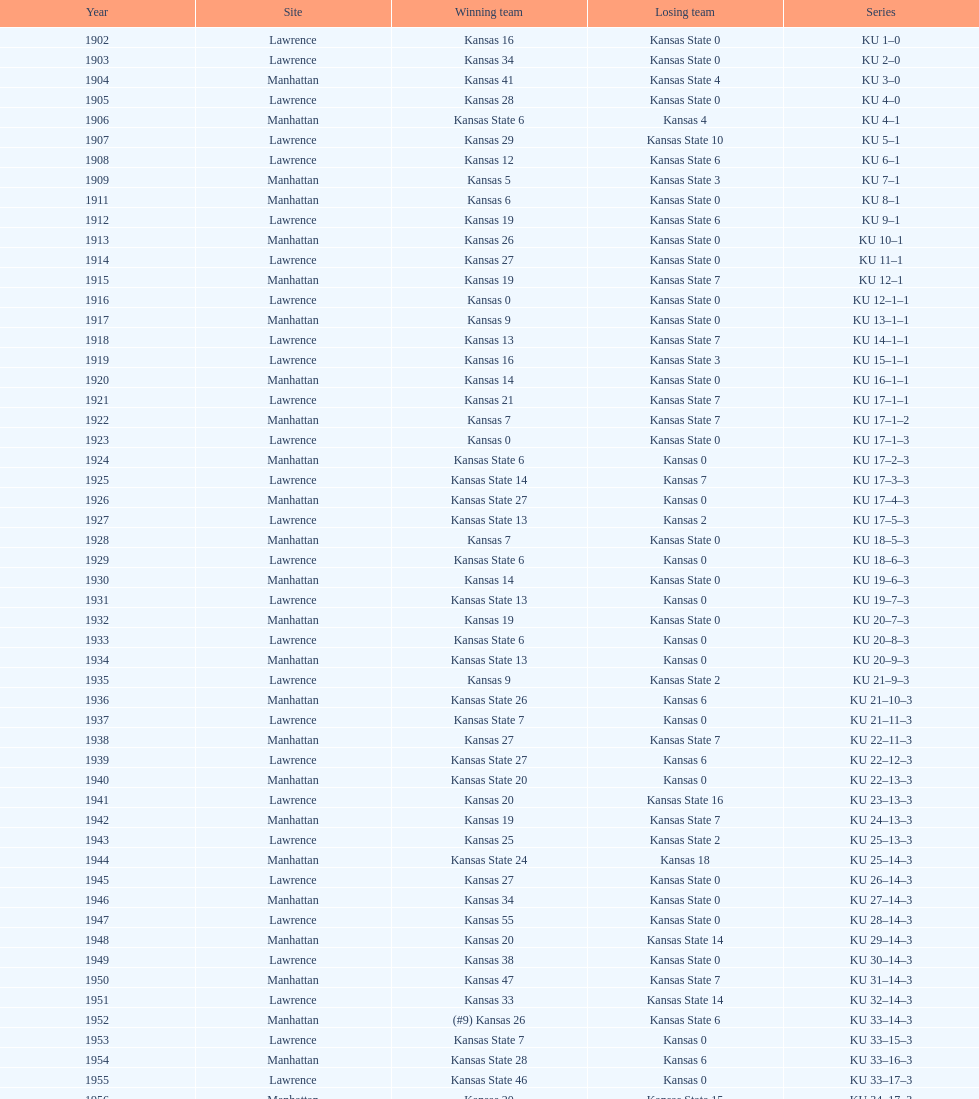Could you parse the entire table? {'header': ['Year', 'Site', 'Winning team', 'Losing team', 'Series'], 'rows': [['1902', 'Lawrence', 'Kansas 16', 'Kansas State 0', 'KU 1–0'], ['1903', 'Lawrence', 'Kansas 34', 'Kansas State 0', 'KU 2–0'], ['1904', 'Manhattan', 'Kansas 41', 'Kansas State 4', 'KU 3–0'], ['1905', 'Lawrence', 'Kansas 28', 'Kansas State 0', 'KU 4–0'], ['1906', 'Manhattan', 'Kansas State 6', 'Kansas 4', 'KU 4–1'], ['1907', 'Lawrence', 'Kansas 29', 'Kansas State 10', 'KU 5–1'], ['1908', 'Lawrence', 'Kansas 12', 'Kansas State 6', 'KU 6–1'], ['1909', 'Manhattan', 'Kansas 5', 'Kansas State 3', 'KU 7–1'], ['1911', 'Manhattan', 'Kansas 6', 'Kansas State 0', 'KU 8–1'], ['1912', 'Lawrence', 'Kansas 19', 'Kansas State 6', 'KU 9–1'], ['1913', 'Manhattan', 'Kansas 26', 'Kansas State 0', 'KU 10–1'], ['1914', 'Lawrence', 'Kansas 27', 'Kansas State 0', 'KU 11–1'], ['1915', 'Manhattan', 'Kansas 19', 'Kansas State 7', 'KU 12–1'], ['1916', 'Lawrence', 'Kansas 0', 'Kansas State 0', 'KU 12–1–1'], ['1917', 'Manhattan', 'Kansas 9', 'Kansas State 0', 'KU 13–1–1'], ['1918', 'Lawrence', 'Kansas 13', 'Kansas State 7', 'KU 14–1–1'], ['1919', 'Lawrence', 'Kansas 16', 'Kansas State 3', 'KU 15–1–1'], ['1920', 'Manhattan', 'Kansas 14', 'Kansas State 0', 'KU 16–1–1'], ['1921', 'Lawrence', 'Kansas 21', 'Kansas State 7', 'KU 17–1–1'], ['1922', 'Manhattan', 'Kansas 7', 'Kansas State 7', 'KU 17–1–2'], ['1923', 'Lawrence', 'Kansas 0', 'Kansas State 0', 'KU 17–1–3'], ['1924', 'Manhattan', 'Kansas State 6', 'Kansas 0', 'KU 17–2–3'], ['1925', 'Lawrence', 'Kansas State 14', 'Kansas 7', 'KU 17–3–3'], ['1926', 'Manhattan', 'Kansas State 27', 'Kansas 0', 'KU 17–4–3'], ['1927', 'Lawrence', 'Kansas State 13', 'Kansas 2', 'KU 17–5–3'], ['1928', 'Manhattan', 'Kansas 7', 'Kansas State 0', 'KU 18–5–3'], ['1929', 'Lawrence', 'Kansas State 6', 'Kansas 0', 'KU 18–6–3'], ['1930', 'Manhattan', 'Kansas 14', 'Kansas State 0', 'KU 19–6–3'], ['1931', 'Lawrence', 'Kansas State 13', 'Kansas 0', 'KU 19–7–3'], ['1932', 'Manhattan', 'Kansas 19', 'Kansas State 0', 'KU 20–7–3'], ['1933', 'Lawrence', 'Kansas State 6', 'Kansas 0', 'KU 20–8–3'], ['1934', 'Manhattan', 'Kansas State 13', 'Kansas 0', 'KU 20–9–3'], ['1935', 'Lawrence', 'Kansas 9', 'Kansas State 2', 'KU 21–9–3'], ['1936', 'Manhattan', 'Kansas State 26', 'Kansas 6', 'KU 21–10–3'], ['1937', 'Lawrence', 'Kansas State 7', 'Kansas 0', 'KU 21–11–3'], ['1938', 'Manhattan', 'Kansas 27', 'Kansas State 7', 'KU 22–11–3'], ['1939', 'Lawrence', 'Kansas State 27', 'Kansas 6', 'KU 22–12–3'], ['1940', 'Manhattan', 'Kansas State 20', 'Kansas 0', 'KU 22–13–3'], ['1941', 'Lawrence', 'Kansas 20', 'Kansas State 16', 'KU 23–13–3'], ['1942', 'Manhattan', 'Kansas 19', 'Kansas State 7', 'KU 24–13–3'], ['1943', 'Lawrence', 'Kansas 25', 'Kansas State 2', 'KU 25–13–3'], ['1944', 'Manhattan', 'Kansas State 24', 'Kansas 18', 'KU 25–14–3'], ['1945', 'Lawrence', 'Kansas 27', 'Kansas State 0', 'KU 26–14–3'], ['1946', 'Manhattan', 'Kansas 34', 'Kansas State 0', 'KU 27–14–3'], ['1947', 'Lawrence', 'Kansas 55', 'Kansas State 0', 'KU 28–14–3'], ['1948', 'Manhattan', 'Kansas 20', 'Kansas State 14', 'KU 29–14–3'], ['1949', 'Lawrence', 'Kansas 38', 'Kansas State 0', 'KU 30–14–3'], ['1950', 'Manhattan', 'Kansas 47', 'Kansas State 7', 'KU 31–14–3'], ['1951', 'Lawrence', 'Kansas 33', 'Kansas State 14', 'KU 32–14–3'], ['1952', 'Manhattan', '(#9) Kansas 26', 'Kansas State 6', 'KU 33–14–3'], ['1953', 'Lawrence', 'Kansas State 7', 'Kansas 0', 'KU 33–15–3'], ['1954', 'Manhattan', 'Kansas State 28', 'Kansas 6', 'KU 33–16–3'], ['1955', 'Lawrence', 'Kansas State 46', 'Kansas 0', 'KU 33–17–3'], ['1956', 'Manhattan', 'Kansas 20', 'Kansas State 15', 'KU 34–17–3'], ['1957', 'Lawrence', 'Kansas 13', 'Kansas State 7', 'KU 35–17–3'], ['1958', 'Manhattan', 'Kansas 21', 'Kansas State 12', 'KU 36–17–3'], ['1959', 'Lawrence', 'Kansas 33', 'Kansas State 14', 'KU 37–17–3'], ['1960', 'Manhattan', 'Kansas 41', 'Kansas State 0', 'KU 38–17–3'], ['1961', 'Lawrence', 'Kansas 34', 'Kansas State 0', 'KU 39–17–3'], ['1962', 'Manhattan', 'Kansas 38', 'Kansas State 0', 'KU 40–17–3'], ['1963', 'Lawrence', 'Kansas 34', 'Kansas State 0', 'KU 41–17–3'], ['1964', 'Manhattan', 'Kansas 7', 'Kansas State 0', 'KU 42–17–3'], ['1965', 'Lawrence', 'Kansas 34', 'Kansas State 0', 'KU 43–17–3'], ['1966', 'Manhattan', 'Kansas 3', 'Kansas State 3', 'KU 43–17–4'], ['1967', 'Lawrence', 'Kansas 17', 'Kansas State 16', 'KU 44–17–4'], ['1968', 'Manhattan', '(#7) Kansas 38', 'Kansas State 29', 'KU 45–17–4']]} When was the first time kansas state won a game with a lead of at least 10 points? 1926. 